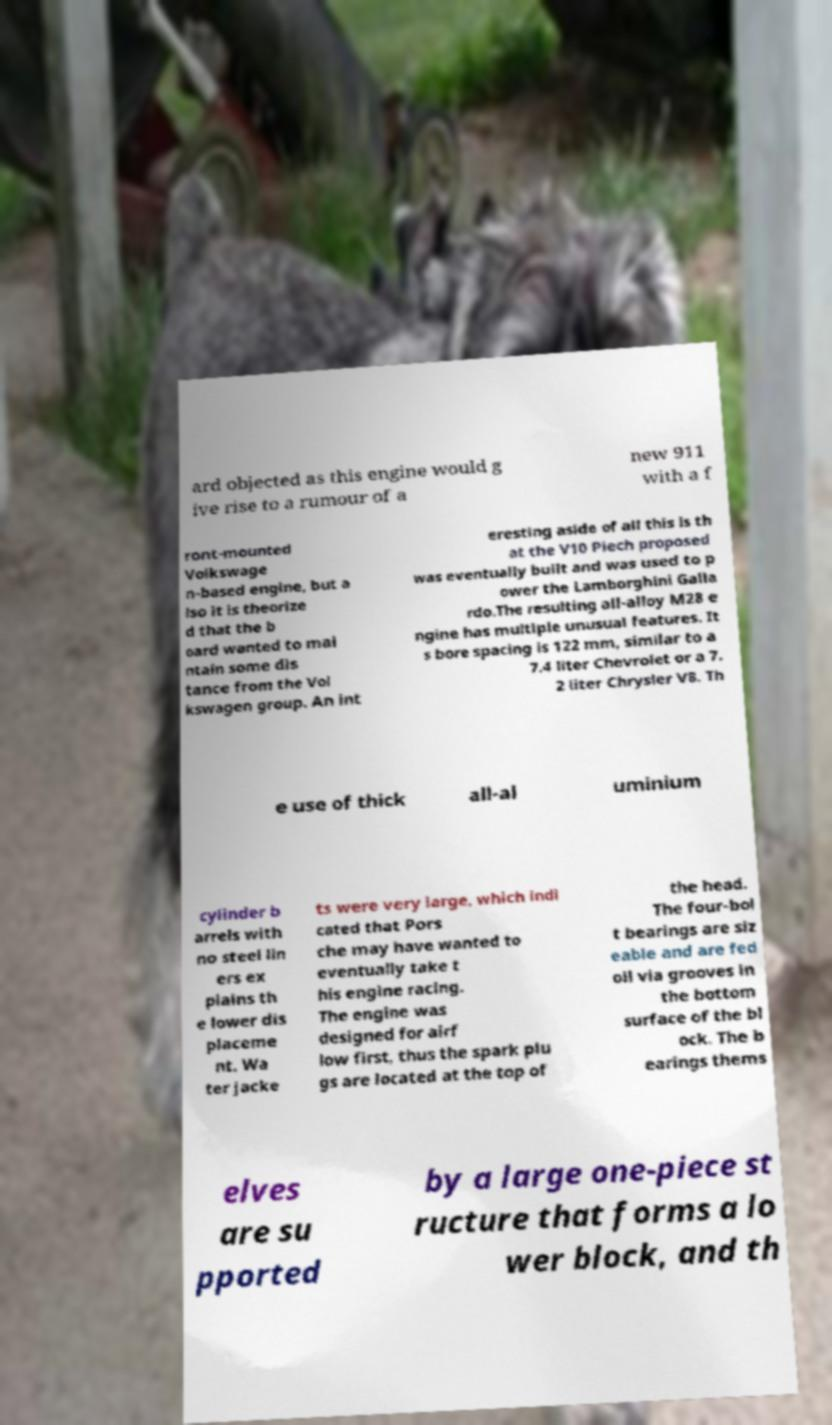Please identify and transcribe the text found in this image. ard objected as this engine would g ive rise to a rumour of a new 911 with a f ront-mounted Volkswage n-based engine, but a lso it is theorize d that the b oard wanted to mai ntain some dis tance from the Vol kswagen group. An int eresting aside of all this is th at the V10 Piech proposed was eventually built and was used to p ower the Lamborghini Galla rdo.The resulting all-alloy M28 e ngine has multiple unusual features. It s bore spacing is 122 mm, similar to a 7.4 liter Chevrolet or a 7. 2 liter Chrysler V8. Th e use of thick all-al uminium cylinder b arrels with no steel lin ers ex plains th e lower dis placeme nt. Wa ter jacke ts were very large, which indi cated that Pors che may have wanted to eventually take t his engine racing. The engine was designed for airf low first, thus the spark plu gs are located at the top of the head. The four-bol t bearings are siz eable and are fed oil via grooves in the bottom surface of the bl ock. The b earings thems elves are su pported by a large one-piece st ructure that forms a lo wer block, and th 